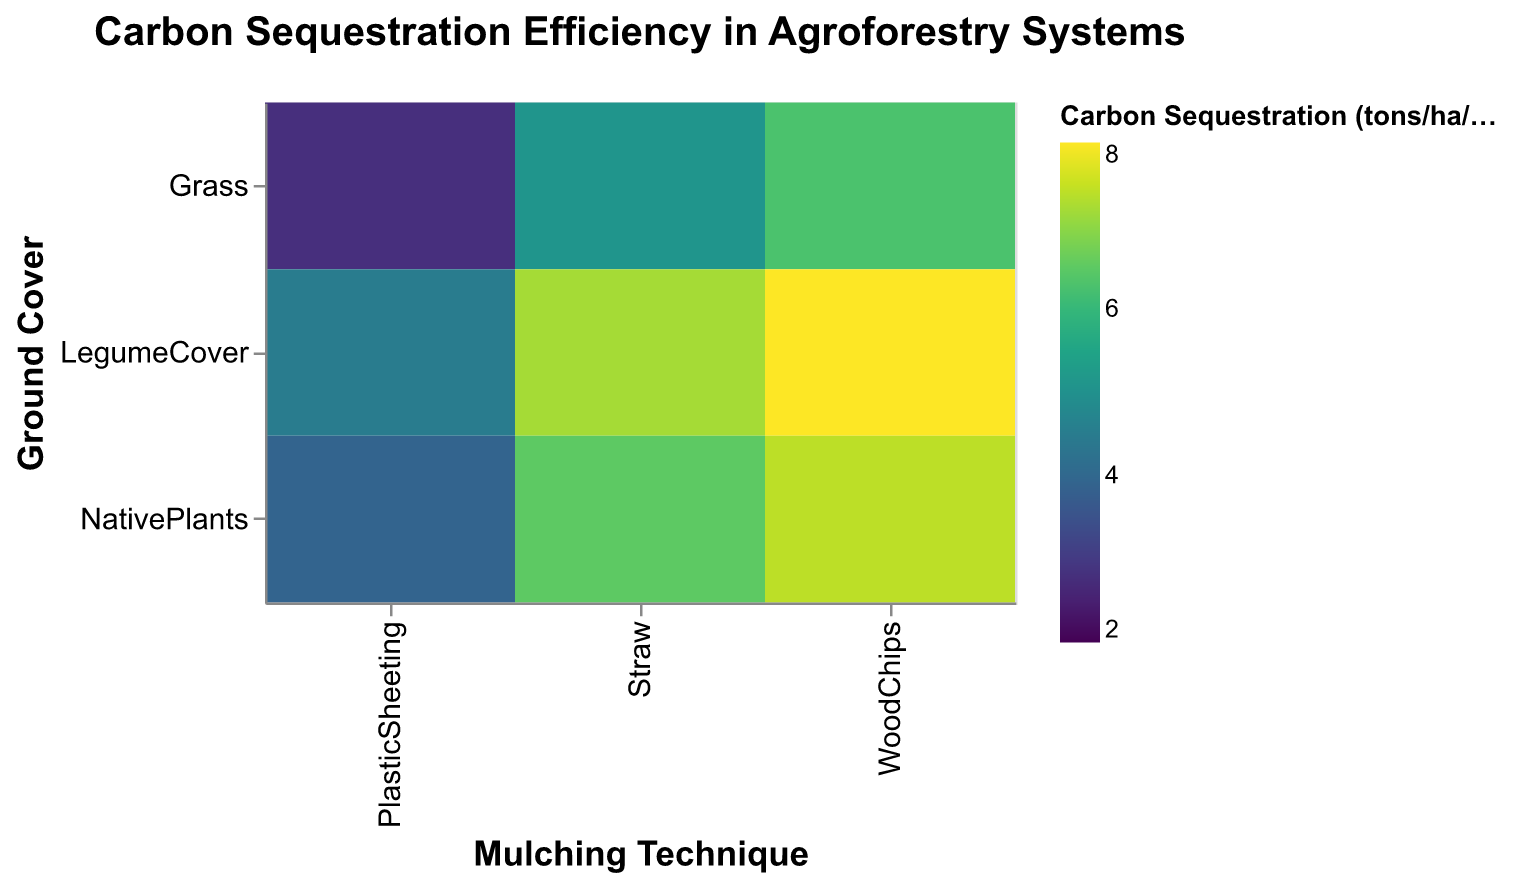What is the title of the heatmap? The title is typically located at the top of the chart, summarizing its purpose or the key message it conveys. This heatmap's title can be found above the plot.
Answer: Carbon Sequestration Efficiency in Agroforestry Systems Which ground cover and mulching technique combination has the highest carbon sequestration value? Look for the darkest color on the heatmap as it represents the highest carbon sequestration value. According to the figure, the darkest color is located at the intersection of "LegumeCover" and "WoodChips".
Answer: Legume Cover and Wood Chips What's the carbon sequestration value for Native Plants with Plastic Sheeting mulching? Find the cell where "Native Plants" on the y-axis intersects with "Plastic Sheeting" on the x-axis. The color of this cell represents the carbon sequestration value, which is also explicitly written within the cell or can be interpreted using the color legend.
Answer: 3.9 How does the carbon sequestration of Grass with Wood Chips compare to Grass with Plastic Sheeting? Identify the cells for "Grass" with "Wood Chips" and "Grass" with "Plastic Sheeting." Notice that the color of Grass with Wood Chips is darker than that of Grass with Plastic Sheeting, indicating a higher carbon sequestration value.
Answer: Grass with Wood Chips has a higher carbon sequestration than Grass with Plastic Sheeting What is the average carbon sequestration value for all mulching techniques used with Legume Cover? Sum the carbon sequestration values for all legume cover techniques: 7.2 (Straw) + 8.0 (Wood Chips) + 4.5 (Plastic Sheeting) = 19.7. Then, divide by the number of techniques, which is 3: 19.7 / 3.
Answer: 6.57 Which mulching technique yields the lowest carbon sequestration for Native Plants? Identify the cells with "Native Plants" on the y-axis and compare the colors. The lightest color is at the intersection with "Plastic Sheeting," indicating the lowest value.
Answer: Plastic Sheeting What's the difference in carbon sequestration between Legume Cover with Straw and Grass with Straw mulching? Identify the values for Legume Cover with Straw (7.2) and Grass with Straw (5.1). Subtract the lower value from the higher value: 7.2 - 5.1.
Answer: 2.1 Among the combinations, which ground cover generally shows the most efficient carbon sequestration? Compare the average color intensity (average carbon sequestration values) of each ground cover. The Legume Cover combinations generally have darker colors, indicating higher carbon sequestration values.
Answer: Legume Cover Which combination has the smallest difference in carbon sequestration values between two techniques? Compare the differences for each ground cover-mulching combination. The smallest difference is between Native Plants with Straw and Wood Chips: 7.4 (WoodChips) - 6.5 (Straw) = 0.9.
Answer: Native Plants with Straw and Wood Chips What's the overall trend observed for Plastic Sheeting as a mulching technique across different ground covers? Observe the colors corresponding to Plastic Sheeting for Grass, Legume Cover, and Native Plants. These colors are generally lighter compared to Straw and Wood Chips, indicating lower carbon sequestration values overall.
Answer: Plastic Sheeting tends to result in lower carbon sequestration across all ground covers 